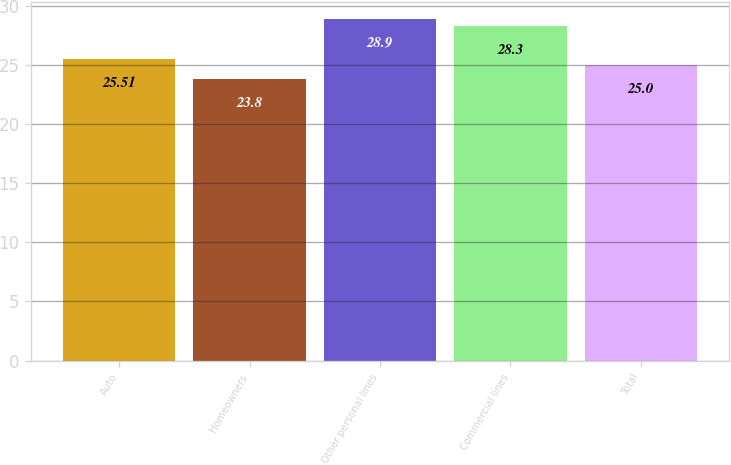<chart> <loc_0><loc_0><loc_500><loc_500><bar_chart><fcel>Auto<fcel>Homeowners<fcel>Other personal lines<fcel>Commercial lines<fcel>Total<nl><fcel>25.51<fcel>23.8<fcel>28.9<fcel>28.3<fcel>25<nl></chart> 